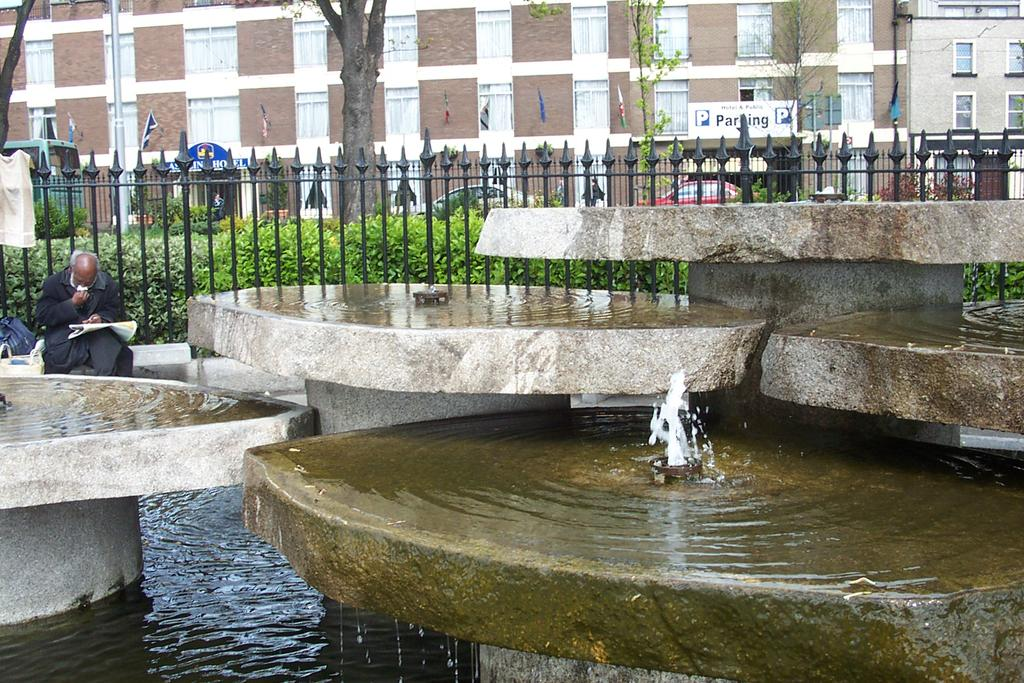What is present in the picture? A: There is water, a man sitting, and an object being held by the man in the picture. What can be seen in the background of the picture? In the background of the picture, there is a fence, plants, buildings, trees, flags, and other unspecified objects. What type of curve can be seen in the image? There is no curve present in the image. Is there a crate visible in the image? There is no crate present in the image. 